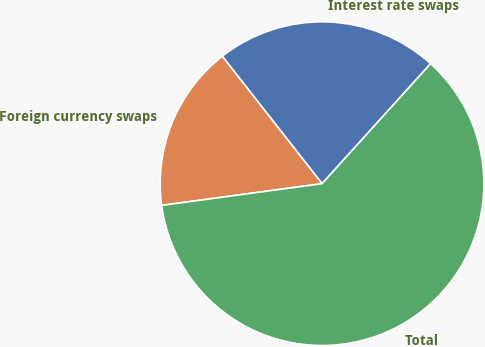<chart> <loc_0><loc_0><loc_500><loc_500><pie_chart><fcel>Interest rate swaps<fcel>Foreign currency swaps<fcel>Total<nl><fcel>22.28%<fcel>16.57%<fcel>61.15%<nl></chart> 